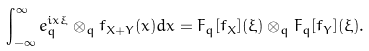<formula> <loc_0><loc_0><loc_500><loc_500>\int _ { - \infty } ^ { \infty } e _ { q } ^ { i x \xi } \otimes _ { q } f _ { X + Y } ( x ) d x = F _ { q } [ f _ { X } ] ( \xi ) \otimes _ { q } F _ { q } [ f _ { Y } ] ( \xi ) .</formula> 